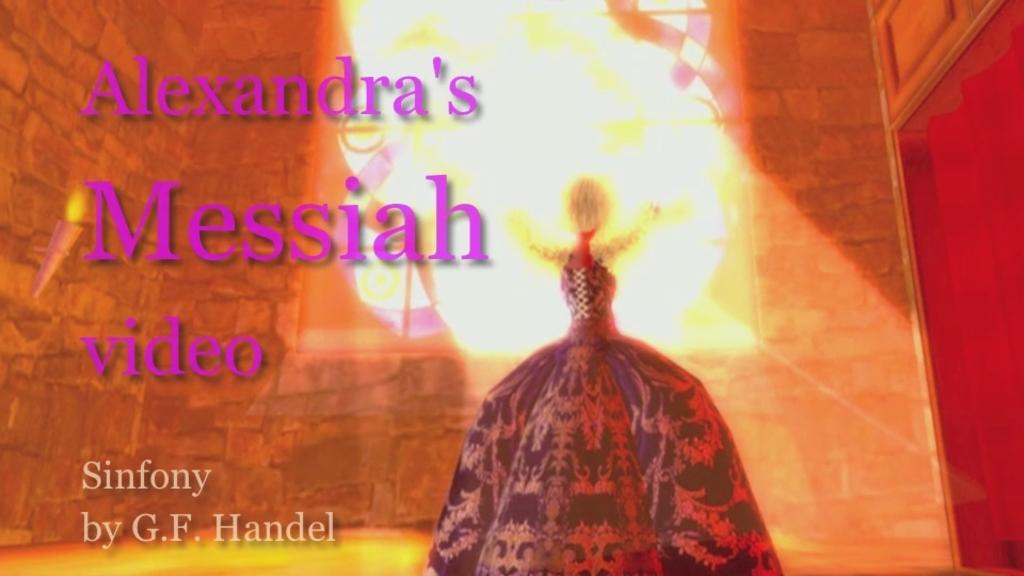Provide a one-sentence caption for the provided image. A video that is titled Alexandra's Messiah Sinfony by G.F. Handel. 